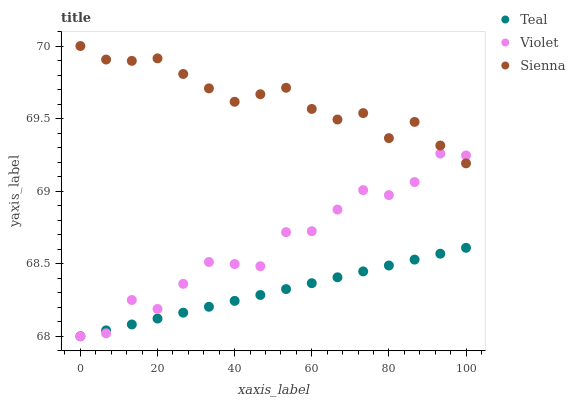Does Teal have the minimum area under the curve?
Answer yes or no. Yes. Does Sienna have the maximum area under the curve?
Answer yes or no. Yes. Does Violet have the minimum area under the curve?
Answer yes or no. No. Does Violet have the maximum area under the curve?
Answer yes or no. No. Is Teal the smoothest?
Answer yes or no. Yes. Is Violet the roughest?
Answer yes or no. Yes. Is Violet the smoothest?
Answer yes or no. No. Is Teal the roughest?
Answer yes or no. No. Does Teal have the lowest value?
Answer yes or no. Yes. Does Sienna have the highest value?
Answer yes or no. Yes. Does Violet have the highest value?
Answer yes or no. No. Is Teal less than Sienna?
Answer yes or no. Yes. Is Sienna greater than Teal?
Answer yes or no. Yes. Does Violet intersect Teal?
Answer yes or no. Yes. Is Violet less than Teal?
Answer yes or no. No. Is Violet greater than Teal?
Answer yes or no. No. Does Teal intersect Sienna?
Answer yes or no. No. 